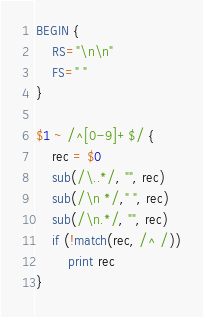Convert code to text. <code><loc_0><loc_0><loc_500><loc_500><_Awk_>BEGIN {
    RS="\n\n"
    FS=" "
}

$1 ~ /^[0-9]+$/ {
    rec = $0
    sub(/\..*/, "", rec)
    sub(/\n */," ", rec)
    sub(/\n.*/, "", rec)
    if (!match(rec, /^ /))
        print rec
}
</code> 